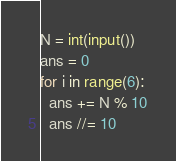Convert code to text. <code><loc_0><loc_0><loc_500><loc_500><_Python_>N = int(input())
ans = 0
for i in range(6):
  ans += N % 10
  ans //= 10</code> 